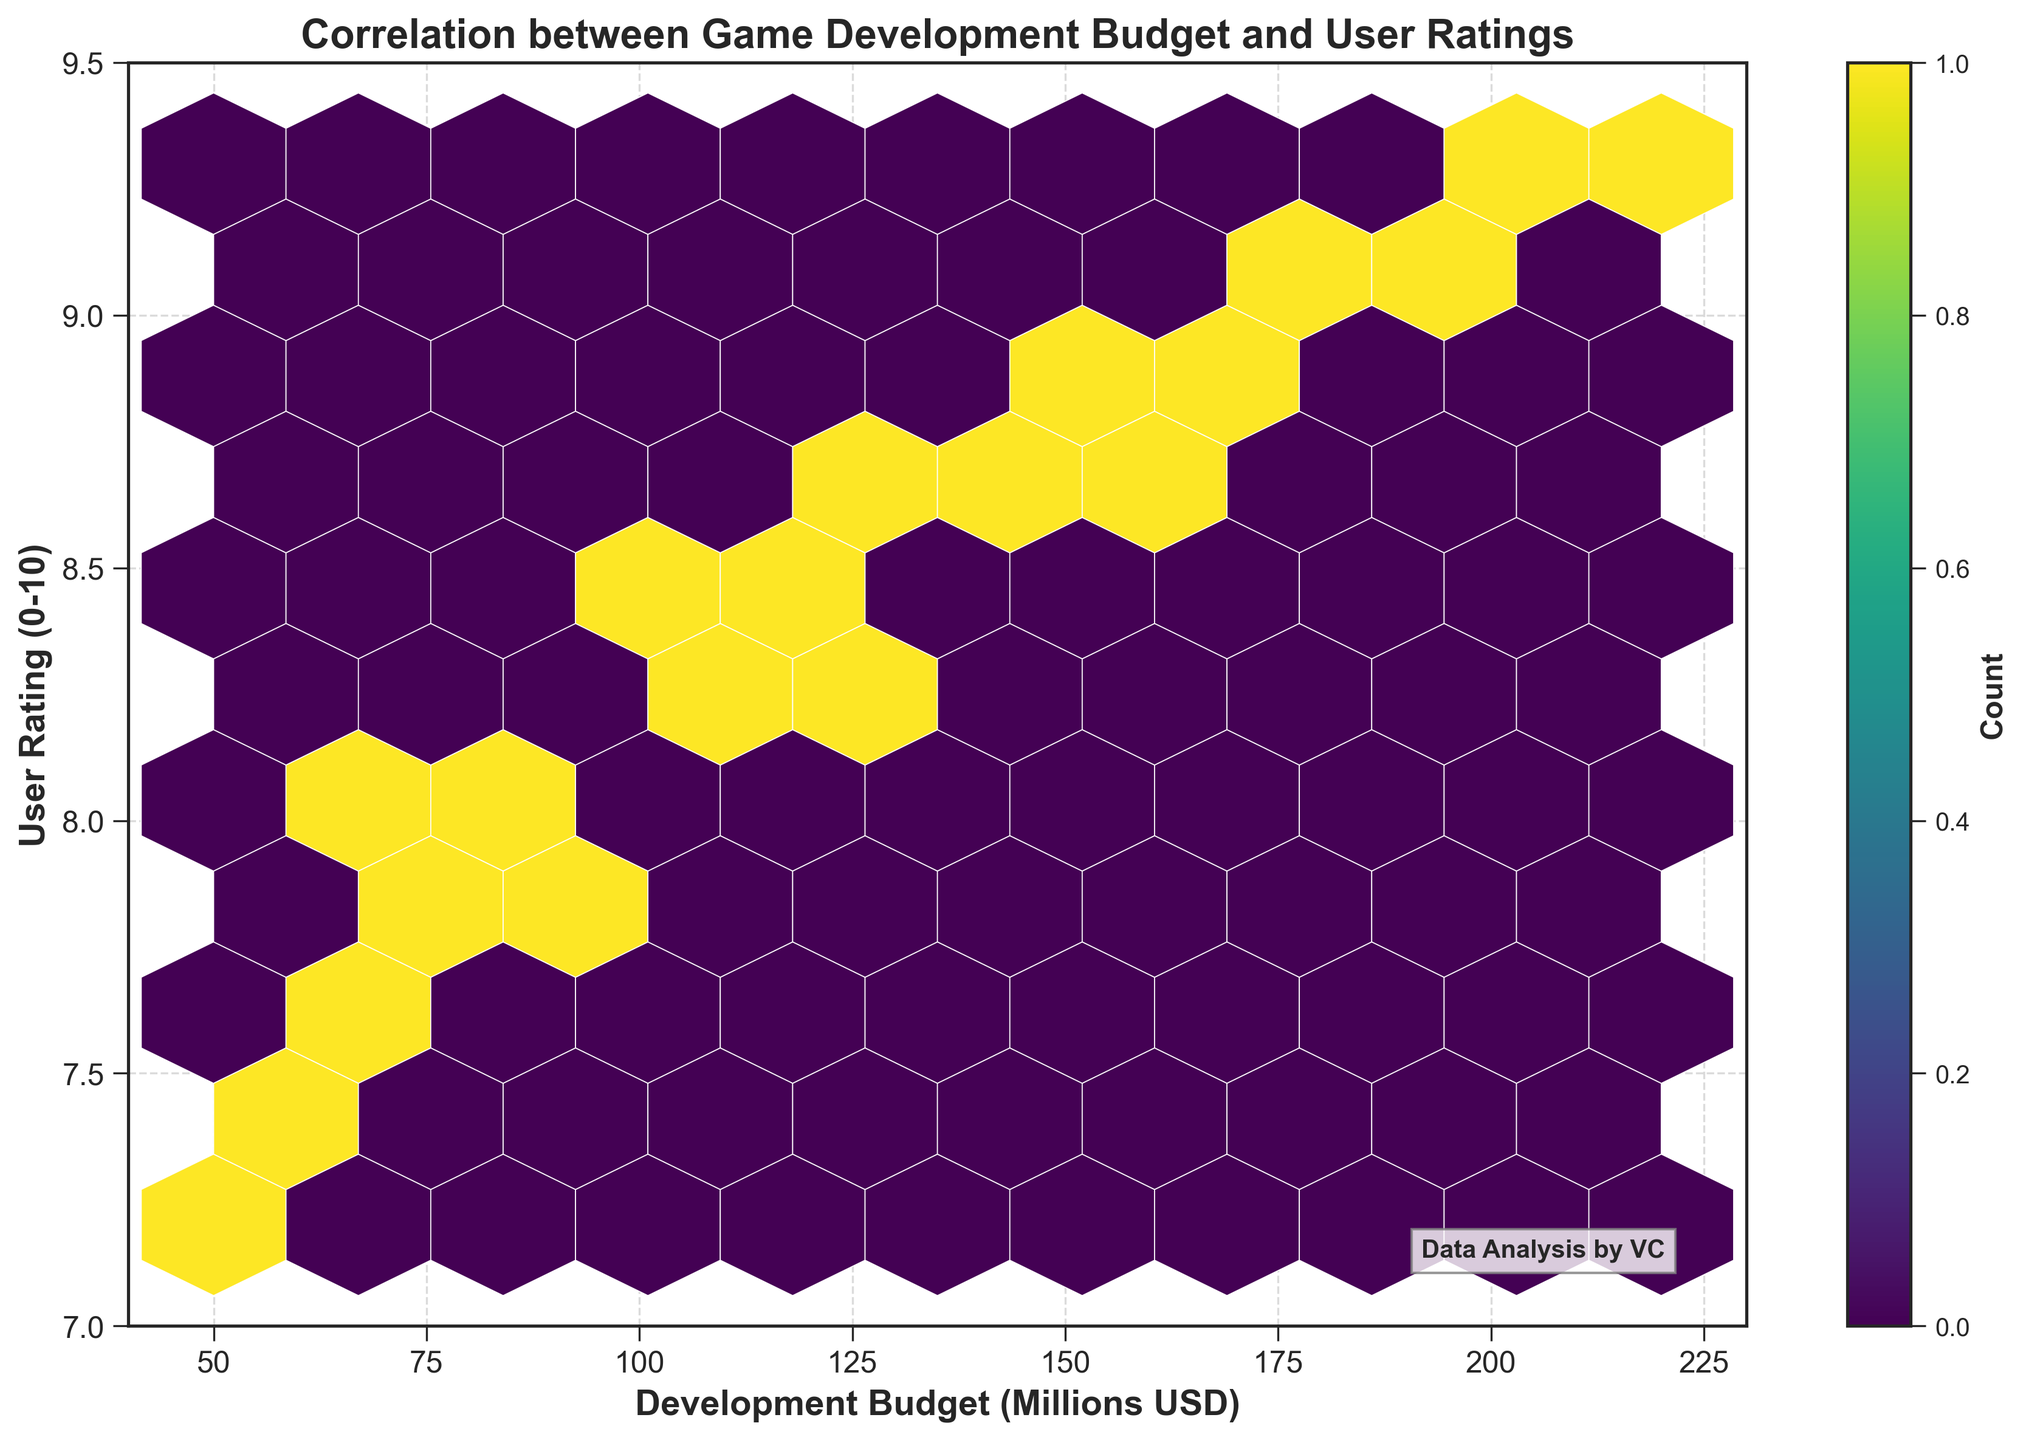What is the title of the Hexbin Plot? The title of the plot is always placed at the top of the figure. It provides an overview of what the plot represents.
Answer: Correlation between Game Development Budget and User Ratings What are the ranges of the x and y axes? The range of the x-axis is from the smallest to the largest value displayed at the bottom of the plot, while the y-axis range is displayed along the left side of the plot.
Answer: 40 to 230 (x-axis) and 7 to 9.5 (y-axis) How dense are the data points around a development budget of 150 million USD and a user rating of 8.9? In a Hexbin plot, density is conveyed by the color intensity within hexagons. Areas with more data points will have darker or more saturated colors.
Answer: Very dense What does the color of each hexagon represent? In Hexbin plots, the color of the hexagons typically represents the number of data points within the bin.
Answer: Count of data points How does user rating generally change with an increase in development budget? By observing the trend in the plot, one can infer how one variable (user rating) changes with another variable (development budget).
Answer: User rating increases Is there any region with low data point density? If so, where is it? By looking at the color and distribution of hexagons, one can locate regions with fewer data points. Lighter colors often indicate such regions.
Answer: Near the bottom-left and top-right corners Is the pattern in the plot linear or non-linear? Examining the general distribution and trend of the data points will help determine if the pattern follows a straight line (linear) or a curve (non-linear).
Answer: Non-linear At which development budget value do we observe the highest user ratings most frequently? By identifying the hexagon with the highest density (darkest color) along the y-axis corresponding to the highest ratings, one can answer this question.
Answer: Around 200 million USD Overall, what general insight can be inferred about the relationship between development budget and user ratings from this Hexbin plot? By summarizing the pattern and trend observed in the plot, one can derive a general insight.
Answer: Higher budgets tend to correspond to higher user ratings 